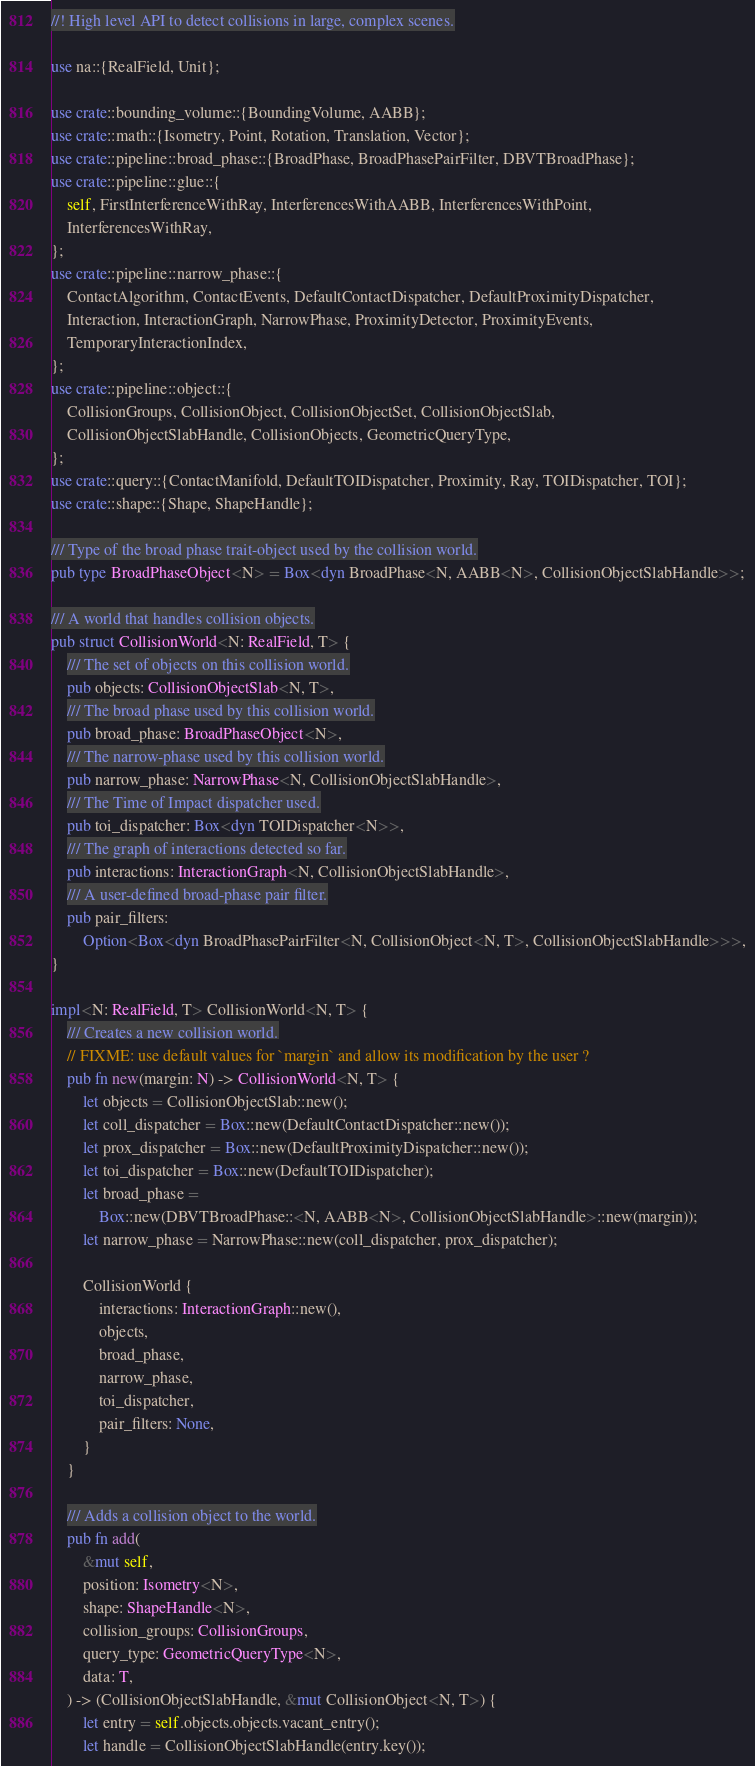Convert code to text. <code><loc_0><loc_0><loc_500><loc_500><_Rust_>//! High level API to detect collisions in large, complex scenes.

use na::{RealField, Unit};

use crate::bounding_volume::{BoundingVolume, AABB};
use crate::math::{Isometry, Point, Rotation, Translation, Vector};
use crate::pipeline::broad_phase::{BroadPhase, BroadPhasePairFilter, DBVTBroadPhase};
use crate::pipeline::glue::{
    self, FirstInterferenceWithRay, InterferencesWithAABB, InterferencesWithPoint,
    InterferencesWithRay,
};
use crate::pipeline::narrow_phase::{
    ContactAlgorithm, ContactEvents, DefaultContactDispatcher, DefaultProximityDispatcher,
    Interaction, InteractionGraph, NarrowPhase, ProximityDetector, ProximityEvents,
    TemporaryInteractionIndex,
};
use crate::pipeline::object::{
    CollisionGroups, CollisionObject, CollisionObjectSet, CollisionObjectSlab,
    CollisionObjectSlabHandle, CollisionObjects, GeometricQueryType,
};
use crate::query::{ContactManifold, DefaultTOIDispatcher, Proximity, Ray, TOIDispatcher, TOI};
use crate::shape::{Shape, ShapeHandle};

/// Type of the broad phase trait-object used by the collision world.
pub type BroadPhaseObject<N> = Box<dyn BroadPhase<N, AABB<N>, CollisionObjectSlabHandle>>;

/// A world that handles collision objects.
pub struct CollisionWorld<N: RealField, T> {
    /// The set of objects on this collision world.
    pub objects: CollisionObjectSlab<N, T>,
    /// The broad phase used by this collision world.
    pub broad_phase: BroadPhaseObject<N>,
    /// The narrow-phase used by this collision world.
    pub narrow_phase: NarrowPhase<N, CollisionObjectSlabHandle>,
    /// The Time of Impact dispatcher used.
    pub toi_dispatcher: Box<dyn TOIDispatcher<N>>,
    /// The graph of interactions detected so far.
    pub interactions: InteractionGraph<N, CollisionObjectSlabHandle>,
    /// A user-defined broad-phase pair filter.
    pub pair_filters:
        Option<Box<dyn BroadPhasePairFilter<N, CollisionObject<N, T>, CollisionObjectSlabHandle>>>,
}

impl<N: RealField, T> CollisionWorld<N, T> {
    /// Creates a new collision world.
    // FIXME: use default values for `margin` and allow its modification by the user ?
    pub fn new(margin: N) -> CollisionWorld<N, T> {
        let objects = CollisionObjectSlab::new();
        let coll_dispatcher = Box::new(DefaultContactDispatcher::new());
        let prox_dispatcher = Box::new(DefaultProximityDispatcher::new());
        let toi_dispatcher = Box::new(DefaultTOIDispatcher);
        let broad_phase =
            Box::new(DBVTBroadPhase::<N, AABB<N>, CollisionObjectSlabHandle>::new(margin));
        let narrow_phase = NarrowPhase::new(coll_dispatcher, prox_dispatcher);

        CollisionWorld {
            interactions: InteractionGraph::new(),
            objects,
            broad_phase,
            narrow_phase,
            toi_dispatcher,
            pair_filters: None,
        }
    }

    /// Adds a collision object to the world.
    pub fn add(
        &mut self,
        position: Isometry<N>,
        shape: ShapeHandle<N>,
        collision_groups: CollisionGroups,
        query_type: GeometricQueryType<N>,
        data: T,
    ) -> (CollisionObjectSlabHandle, &mut CollisionObject<N, T>) {
        let entry = self.objects.objects.vacant_entry();
        let handle = CollisionObjectSlabHandle(entry.key());</code> 